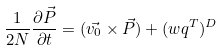<formula> <loc_0><loc_0><loc_500><loc_500>\frac { 1 } { 2 N } \frac { \partial \vec { P } } { \partial t } = ( \vec { v _ { 0 } } \times \vec { P } ) + ( w q ^ { T } ) ^ { D }</formula> 